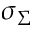<formula> <loc_0><loc_0><loc_500><loc_500>\sigma _ { \Sigma }</formula> 